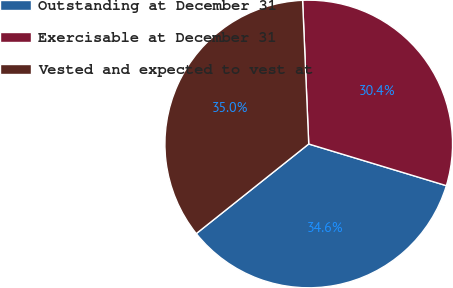Convert chart to OTSL. <chart><loc_0><loc_0><loc_500><loc_500><pie_chart><fcel>Outstanding at December 31<fcel>Exercisable at December 31<fcel>Vested and expected to vest at<nl><fcel>34.61%<fcel>30.36%<fcel>35.03%<nl></chart> 